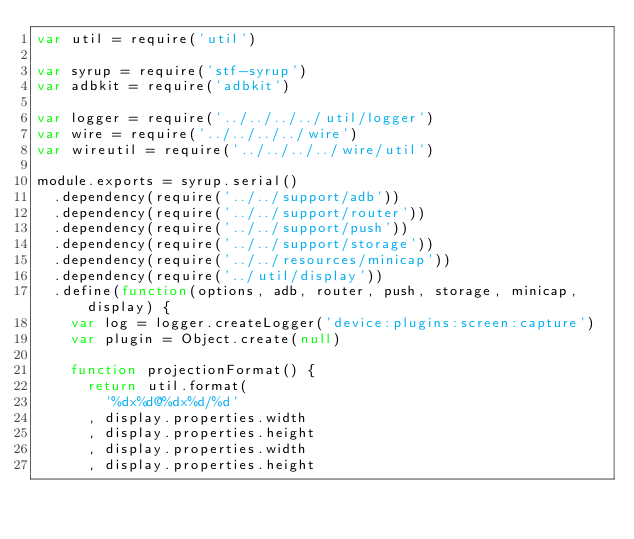<code> <loc_0><loc_0><loc_500><loc_500><_JavaScript_>var util = require('util')

var syrup = require('stf-syrup')
var adbkit = require('adbkit')

var logger = require('../../../../util/logger')
var wire = require('../../../../wire')
var wireutil = require('../../../../wire/util')

module.exports = syrup.serial()
  .dependency(require('../../support/adb'))
  .dependency(require('../../support/router'))
  .dependency(require('../../support/push'))
  .dependency(require('../../support/storage'))
  .dependency(require('../../resources/minicap'))
  .dependency(require('../util/display'))
  .define(function(options, adb, router, push, storage, minicap, display) {
    var log = logger.createLogger('device:plugins:screen:capture')
    var plugin = Object.create(null)

    function projectionFormat() {
      return util.format(
        '%dx%d@%dx%d/%d'
      , display.properties.width
      , display.properties.height
      , display.properties.width
      , display.properties.height</code> 